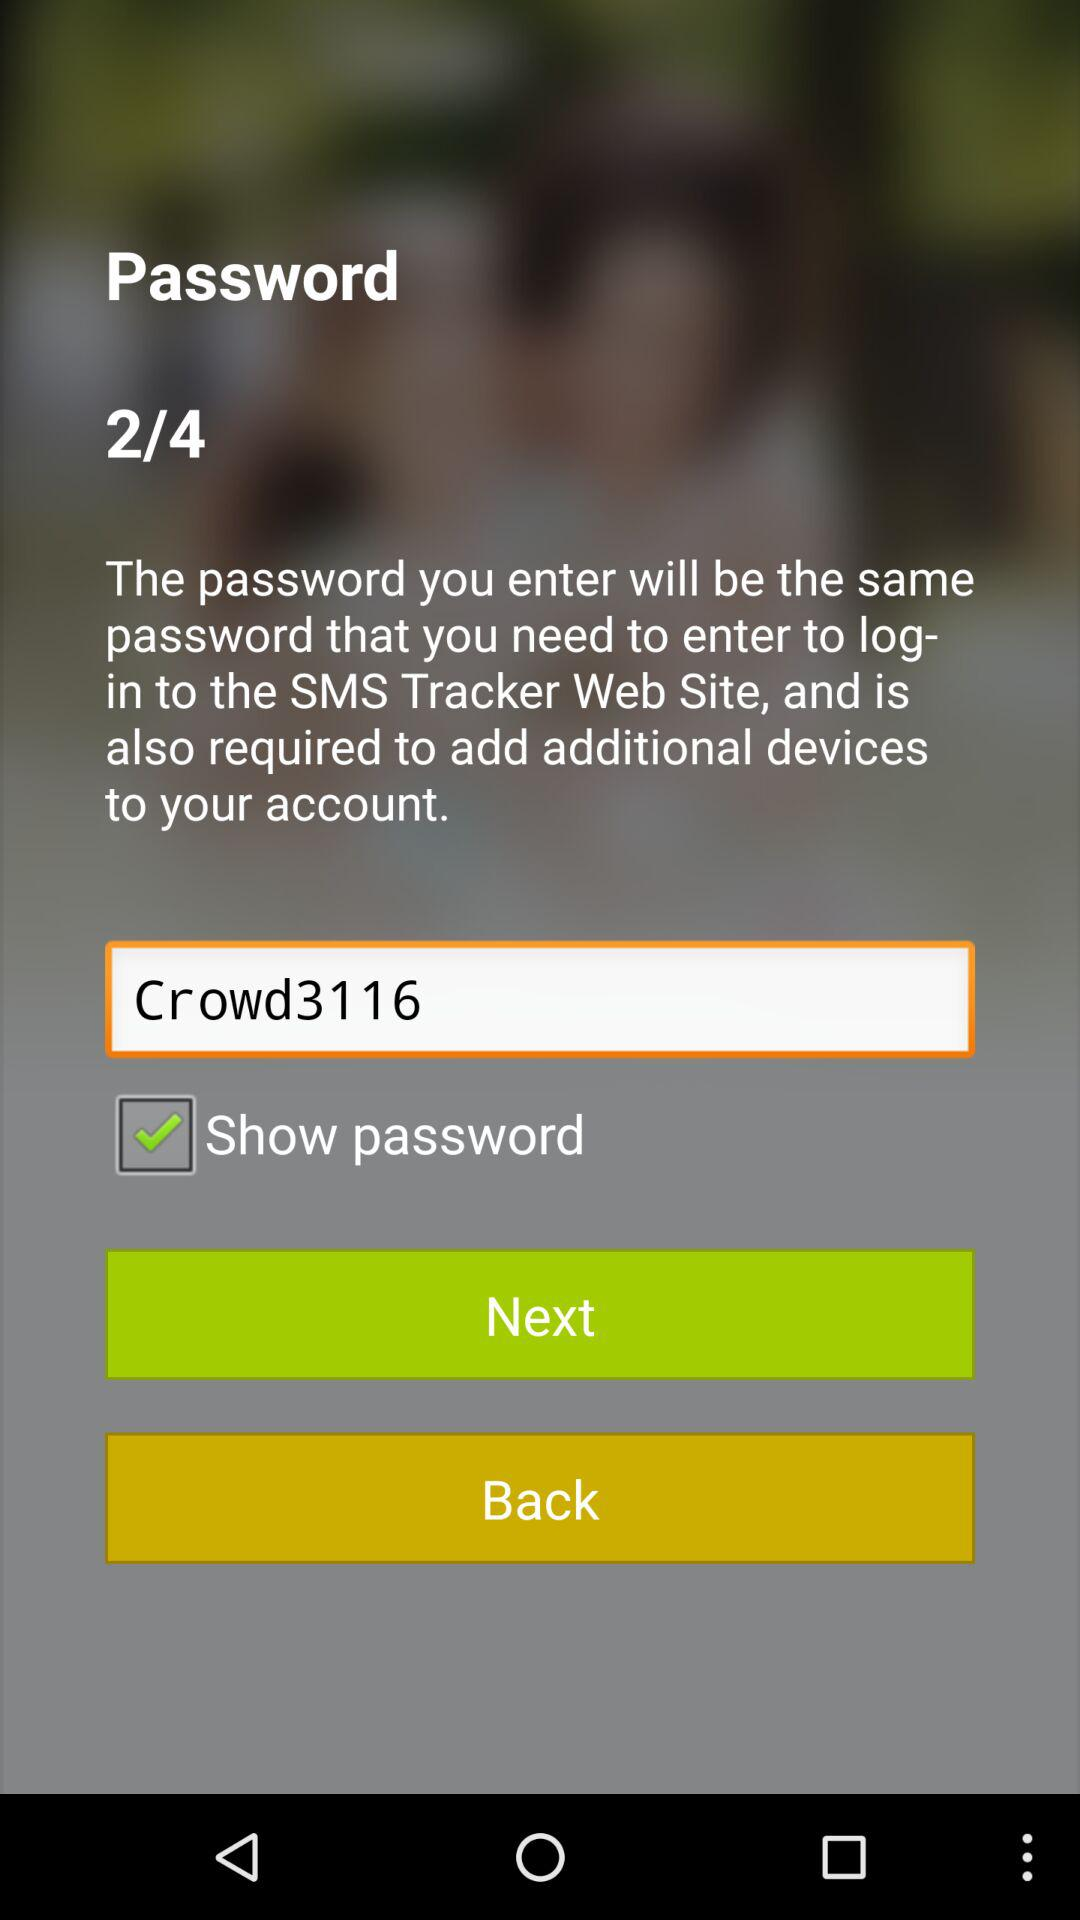How many total pages are there? There are a total of 4 pages. 